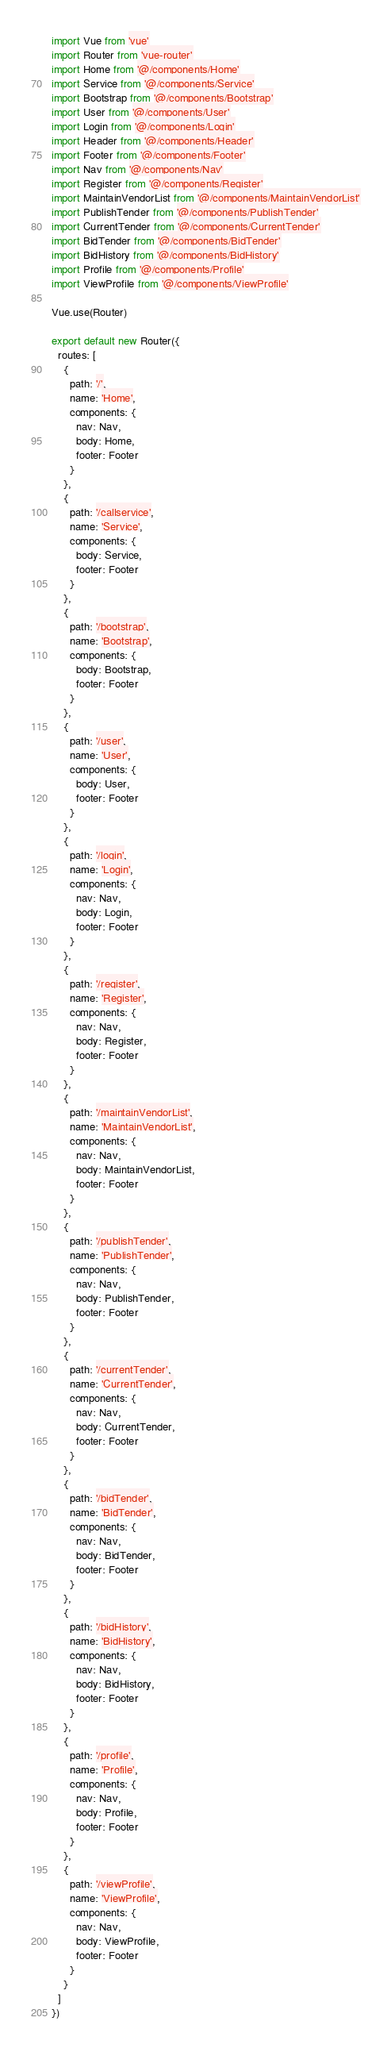<code> <loc_0><loc_0><loc_500><loc_500><_JavaScript_>import Vue from 'vue'
import Router from 'vue-router'
import Home from '@/components/Home'
import Service from '@/components/Service'
import Bootstrap from '@/components/Bootstrap'
import User from '@/components/User'
import Login from '@/components/Login'
import Header from '@/components/Header'
import Footer from '@/components/Footer'
import Nav from '@/components/Nav'
import Register from '@/components/Register'
import MaintainVendorList from '@/components/MaintainVendorList'
import PublishTender from '@/components/PublishTender'
import CurrentTender from '@/components/CurrentTender'
import BidTender from '@/components/BidTender'
import BidHistory from '@/components/BidHistory'
import Profile from '@/components/Profile'
import ViewProfile from '@/components/ViewProfile'

Vue.use(Router)

export default new Router({
  routes: [
    {
      path: '/',
      name: 'Home',
      components: {
        nav: Nav,
        body: Home,
        footer: Footer
      }
    },
    {
      path: '/callservice',
      name: 'Service',
      components: {
        body: Service,
        footer: Footer
      }
    },
    {
      path: '/bootstrap',
      name: 'Bootstrap',
      components: {
        body: Bootstrap,
        footer: Footer
      }
    },
    {
      path: '/user',
      name: 'User',
      components: {
        body: User,
        footer: Footer
      }
    },
    {
      path: '/login',
      name: 'Login',
      components: {
        nav: Nav,
        body: Login,        
        footer: Footer
      }
    },
    {
      path: '/register',
      name: 'Register',
      components: {
        nav: Nav,
        body: Register,
        footer: Footer
      }
    },
    {
      path: '/maintainVendorList',
      name: 'MaintainVendorList',
      components: {
        nav: Nav,
        body: MaintainVendorList,
        footer: Footer
      }
    },
    {
      path: '/publishTender',
      name: 'PublishTender',
      components: {
        nav: Nav,
        body: PublishTender,
        footer: Footer
      }
    },
    {
      path: '/currentTender',
      name: 'CurrentTender',
      components: {
        nav: Nav,
        body: CurrentTender,
        footer: Footer
      }
    },
    {
      path: '/bidTender',
      name: 'BidTender',
      components: {
        nav: Nav,
        body: BidTender,
        footer: Footer
      }
    },
    {
      path: '/bidHistory',
      name: 'BidHistory',
      components: {
        nav: Nav,
        body: BidHistory,
        footer: Footer
      }
    },
    {
      path: '/profile',
      name: 'Profile',
      components: {
        nav: Nav,
        body: Profile,
        footer: Footer
      }
    },
    {
      path: '/viewProfile',
      name: 'ViewProfile',
      components: {
        nav: Nav,
        body: ViewProfile,
        footer: Footer
      }
    }
  ]
})
</code> 